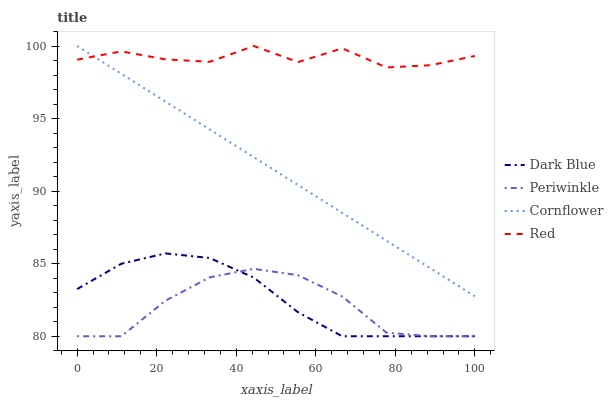Does Periwinkle have the minimum area under the curve?
Answer yes or no. Yes. Does Red have the maximum area under the curve?
Answer yes or no. Yes. Does Red have the minimum area under the curve?
Answer yes or no. No. Does Periwinkle have the maximum area under the curve?
Answer yes or no. No. Is Cornflower the smoothest?
Answer yes or no. Yes. Is Red the roughest?
Answer yes or no. Yes. Is Periwinkle the smoothest?
Answer yes or no. No. Is Periwinkle the roughest?
Answer yes or no. No. Does Red have the lowest value?
Answer yes or no. No. Does Cornflower have the highest value?
Answer yes or no. Yes. Does Periwinkle have the highest value?
Answer yes or no. No. Is Periwinkle less than Red?
Answer yes or no. Yes. Is Cornflower greater than Dark Blue?
Answer yes or no. Yes. Does Cornflower intersect Red?
Answer yes or no. Yes. Is Cornflower less than Red?
Answer yes or no. No. Is Cornflower greater than Red?
Answer yes or no. No. Does Periwinkle intersect Red?
Answer yes or no. No. 